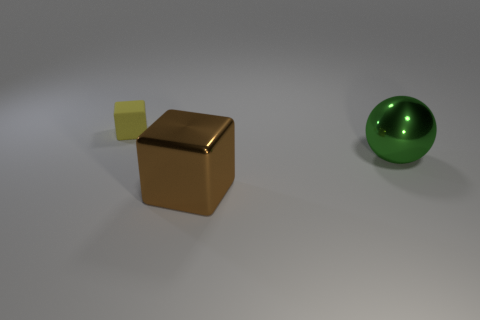Are there any purple rubber cubes that have the same size as the green ball? no 